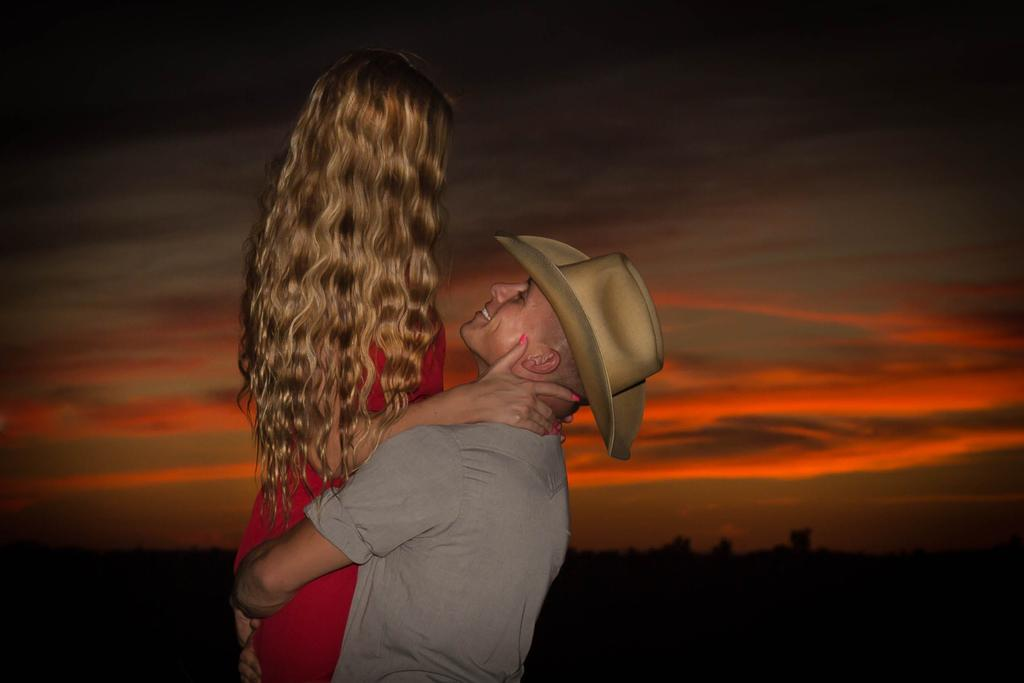How many people can be seen in the image? There are a few people in the image. What can be seen in the background of the image? The background of the image is visible. What part of the natural environment is visible in the image? The sky is visible in the image. What is the condition of the sky in the image? Clouds are present in the sky. What type of brush can be seen in the image? There is no brush present in the image. How many feet are visible in the image? There is no mention of feet in the image, as the focus is on the people and the sky. 